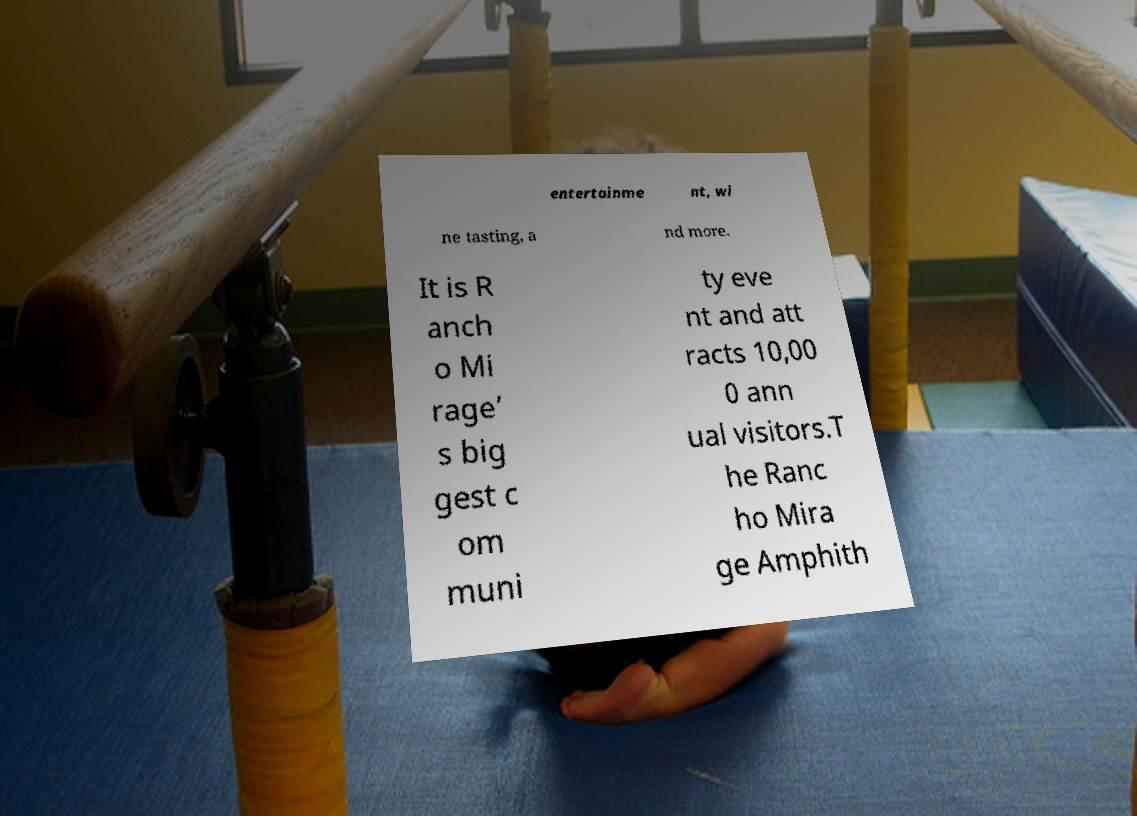There's text embedded in this image that I need extracted. Can you transcribe it verbatim? entertainme nt, wi ne tasting, a nd more. It is R anch o Mi rage’ s big gest c om muni ty eve nt and att racts 10,00 0 ann ual visitors.T he Ranc ho Mira ge Amphith 